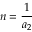Convert formula to latex. <formula><loc_0><loc_0><loc_500><loc_500>n = \frac { 1 } { a _ { 2 } }</formula> 